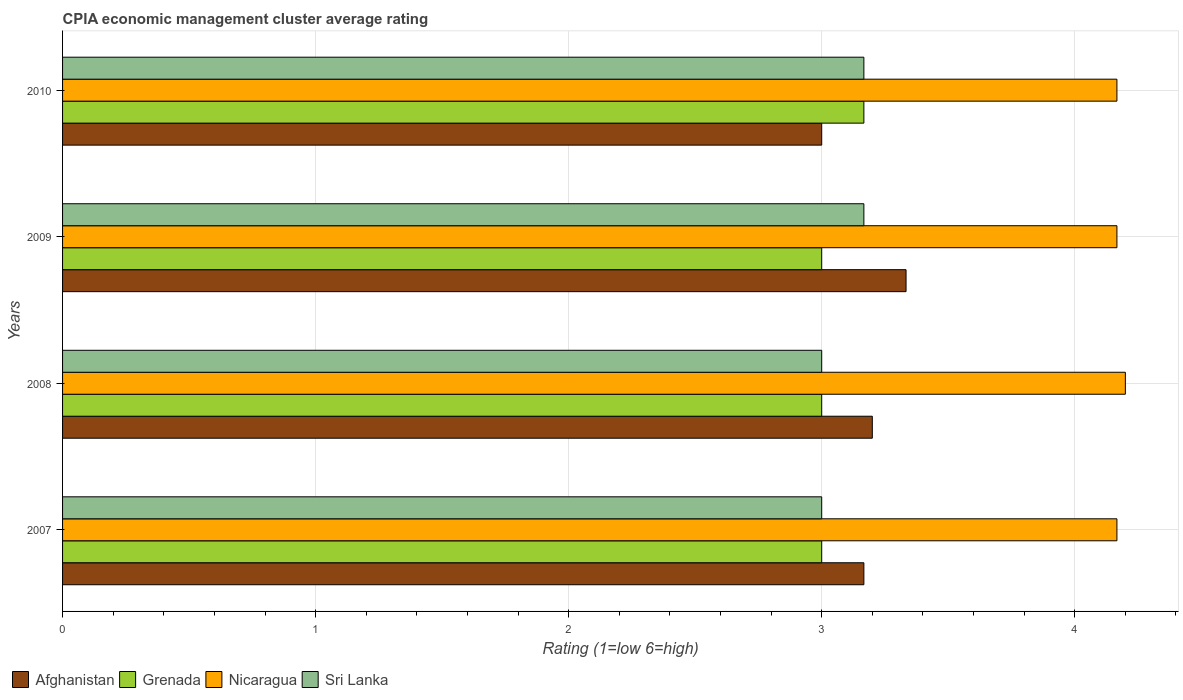How many different coloured bars are there?
Ensure brevity in your answer.  4. Are the number of bars per tick equal to the number of legend labels?
Offer a terse response. Yes. Are the number of bars on each tick of the Y-axis equal?
Your answer should be very brief. Yes. How many bars are there on the 2nd tick from the top?
Provide a succinct answer. 4. How many bars are there on the 3rd tick from the bottom?
Make the answer very short. 4. What is the CPIA rating in Nicaragua in 2007?
Provide a succinct answer. 4.17. Across all years, what is the maximum CPIA rating in Grenada?
Offer a terse response. 3.17. In which year was the CPIA rating in Afghanistan maximum?
Keep it short and to the point. 2009. What is the total CPIA rating in Afghanistan in the graph?
Provide a succinct answer. 12.7. What is the difference between the CPIA rating in Afghanistan in 2007 and that in 2009?
Offer a very short reply. -0.17. What is the difference between the CPIA rating in Nicaragua in 2009 and the CPIA rating in Afghanistan in 2007?
Provide a short and direct response. 1. What is the average CPIA rating in Nicaragua per year?
Give a very brief answer. 4.18. In the year 2009, what is the difference between the CPIA rating in Nicaragua and CPIA rating in Grenada?
Provide a succinct answer. 1.17. In how many years, is the CPIA rating in Afghanistan greater than 2.4 ?
Your answer should be compact. 4. What is the ratio of the CPIA rating in Sri Lanka in 2007 to that in 2010?
Offer a very short reply. 0.95. Is the CPIA rating in Grenada in 2007 less than that in 2009?
Offer a very short reply. No. What is the difference between the highest and the second highest CPIA rating in Afghanistan?
Make the answer very short. 0.13. What is the difference between the highest and the lowest CPIA rating in Afghanistan?
Make the answer very short. 0.33. In how many years, is the CPIA rating in Afghanistan greater than the average CPIA rating in Afghanistan taken over all years?
Provide a short and direct response. 2. Is the sum of the CPIA rating in Afghanistan in 2008 and 2010 greater than the maximum CPIA rating in Grenada across all years?
Keep it short and to the point. Yes. What does the 4th bar from the top in 2007 represents?
Provide a short and direct response. Afghanistan. What does the 4th bar from the bottom in 2008 represents?
Make the answer very short. Sri Lanka. How many bars are there?
Provide a succinct answer. 16. What is the difference between two consecutive major ticks on the X-axis?
Offer a terse response. 1. Are the values on the major ticks of X-axis written in scientific E-notation?
Offer a very short reply. No. Does the graph contain any zero values?
Make the answer very short. No. Does the graph contain grids?
Your answer should be compact. Yes. How many legend labels are there?
Offer a very short reply. 4. How are the legend labels stacked?
Provide a succinct answer. Horizontal. What is the title of the graph?
Provide a short and direct response. CPIA economic management cluster average rating. Does "Germany" appear as one of the legend labels in the graph?
Provide a succinct answer. No. What is the label or title of the X-axis?
Ensure brevity in your answer.  Rating (1=low 6=high). What is the Rating (1=low 6=high) in Afghanistan in 2007?
Your response must be concise. 3.17. What is the Rating (1=low 6=high) in Grenada in 2007?
Your response must be concise. 3. What is the Rating (1=low 6=high) in Nicaragua in 2007?
Ensure brevity in your answer.  4.17. What is the Rating (1=low 6=high) in Nicaragua in 2008?
Your answer should be compact. 4.2. What is the Rating (1=low 6=high) in Afghanistan in 2009?
Ensure brevity in your answer.  3.33. What is the Rating (1=low 6=high) in Grenada in 2009?
Make the answer very short. 3. What is the Rating (1=low 6=high) of Nicaragua in 2009?
Offer a very short reply. 4.17. What is the Rating (1=low 6=high) of Sri Lanka in 2009?
Give a very brief answer. 3.17. What is the Rating (1=low 6=high) of Grenada in 2010?
Keep it short and to the point. 3.17. What is the Rating (1=low 6=high) of Nicaragua in 2010?
Ensure brevity in your answer.  4.17. What is the Rating (1=low 6=high) of Sri Lanka in 2010?
Keep it short and to the point. 3.17. Across all years, what is the maximum Rating (1=low 6=high) of Afghanistan?
Keep it short and to the point. 3.33. Across all years, what is the maximum Rating (1=low 6=high) in Grenada?
Your answer should be compact. 3.17. Across all years, what is the maximum Rating (1=low 6=high) in Nicaragua?
Your answer should be very brief. 4.2. Across all years, what is the maximum Rating (1=low 6=high) of Sri Lanka?
Your answer should be very brief. 3.17. Across all years, what is the minimum Rating (1=low 6=high) of Afghanistan?
Give a very brief answer. 3. Across all years, what is the minimum Rating (1=low 6=high) in Grenada?
Offer a terse response. 3. Across all years, what is the minimum Rating (1=low 6=high) of Nicaragua?
Offer a very short reply. 4.17. Across all years, what is the minimum Rating (1=low 6=high) of Sri Lanka?
Provide a succinct answer. 3. What is the total Rating (1=low 6=high) of Grenada in the graph?
Give a very brief answer. 12.17. What is the total Rating (1=low 6=high) in Nicaragua in the graph?
Your answer should be very brief. 16.7. What is the total Rating (1=low 6=high) in Sri Lanka in the graph?
Make the answer very short. 12.33. What is the difference between the Rating (1=low 6=high) in Afghanistan in 2007 and that in 2008?
Provide a succinct answer. -0.03. What is the difference between the Rating (1=low 6=high) in Grenada in 2007 and that in 2008?
Give a very brief answer. 0. What is the difference between the Rating (1=low 6=high) of Nicaragua in 2007 and that in 2008?
Make the answer very short. -0.03. What is the difference between the Rating (1=low 6=high) in Afghanistan in 2007 and that in 2009?
Provide a succinct answer. -0.17. What is the difference between the Rating (1=low 6=high) in Sri Lanka in 2007 and that in 2009?
Give a very brief answer. -0.17. What is the difference between the Rating (1=low 6=high) in Grenada in 2007 and that in 2010?
Offer a terse response. -0.17. What is the difference between the Rating (1=low 6=high) in Nicaragua in 2007 and that in 2010?
Give a very brief answer. 0. What is the difference between the Rating (1=low 6=high) in Sri Lanka in 2007 and that in 2010?
Your answer should be very brief. -0.17. What is the difference between the Rating (1=low 6=high) of Afghanistan in 2008 and that in 2009?
Your answer should be compact. -0.13. What is the difference between the Rating (1=low 6=high) in Grenada in 2008 and that in 2010?
Keep it short and to the point. -0.17. What is the difference between the Rating (1=low 6=high) in Sri Lanka in 2008 and that in 2010?
Your response must be concise. -0.17. What is the difference between the Rating (1=low 6=high) in Nicaragua in 2009 and that in 2010?
Make the answer very short. 0. What is the difference between the Rating (1=low 6=high) of Afghanistan in 2007 and the Rating (1=low 6=high) of Nicaragua in 2008?
Your answer should be compact. -1.03. What is the difference between the Rating (1=low 6=high) in Grenada in 2007 and the Rating (1=low 6=high) in Nicaragua in 2008?
Your answer should be very brief. -1.2. What is the difference between the Rating (1=low 6=high) in Grenada in 2007 and the Rating (1=low 6=high) in Sri Lanka in 2008?
Your answer should be very brief. 0. What is the difference between the Rating (1=low 6=high) in Nicaragua in 2007 and the Rating (1=low 6=high) in Sri Lanka in 2008?
Your answer should be compact. 1.17. What is the difference between the Rating (1=low 6=high) in Afghanistan in 2007 and the Rating (1=low 6=high) in Grenada in 2009?
Provide a short and direct response. 0.17. What is the difference between the Rating (1=low 6=high) in Afghanistan in 2007 and the Rating (1=low 6=high) in Sri Lanka in 2009?
Your answer should be compact. 0. What is the difference between the Rating (1=low 6=high) in Grenada in 2007 and the Rating (1=low 6=high) in Nicaragua in 2009?
Keep it short and to the point. -1.17. What is the difference between the Rating (1=low 6=high) of Afghanistan in 2007 and the Rating (1=low 6=high) of Grenada in 2010?
Provide a succinct answer. 0. What is the difference between the Rating (1=low 6=high) of Grenada in 2007 and the Rating (1=low 6=high) of Nicaragua in 2010?
Your response must be concise. -1.17. What is the difference between the Rating (1=low 6=high) in Grenada in 2007 and the Rating (1=low 6=high) in Sri Lanka in 2010?
Ensure brevity in your answer.  -0.17. What is the difference between the Rating (1=low 6=high) in Nicaragua in 2007 and the Rating (1=low 6=high) in Sri Lanka in 2010?
Provide a short and direct response. 1. What is the difference between the Rating (1=low 6=high) of Afghanistan in 2008 and the Rating (1=low 6=high) of Grenada in 2009?
Keep it short and to the point. 0.2. What is the difference between the Rating (1=low 6=high) in Afghanistan in 2008 and the Rating (1=low 6=high) in Nicaragua in 2009?
Your response must be concise. -0.97. What is the difference between the Rating (1=low 6=high) in Afghanistan in 2008 and the Rating (1=low 6=high) in Sri Lanka in 2009?
Offer a very short reply. 0.03. What is the difference between the Rating (1=low 6=high) in Grenada in 2008 and the Rating (1=low 6=high) in Nicaragua in 2009?
Offer a very short reply. -1.17. What is the difference between the Rating (1=low 6=high) of Grenada in 2008 and the Rating (1=low 6=high) of Sri Lanka in 2009?
Your response must be concise. -0.17. What is the difference between the Rating (1=low 6=high) of Afghanistan in 2008 and the Rating (1=low 6=high) of Grenada in 2010?
Your response must be concise. 0.03. What is the difference between the Rating (1=low 6=high) in Afghanistan in 2008 and the Rating (1=low 6=high) in Nicaragua in 2010?
Offer a very short reply. -0.97. What is the difference between the Rating (1=low 6=high) in Afghanistan in 2008 and the Rating (1=low 6=high) in Sri Lanka in 2010?
Your answer should be very brief. 0.03. What is the difference between the Rating (1=low 6=high) of Grenada in 2008 and the Rating (1=low 6=high) of Nicaragua in 2010?
Keep it short and to the point. -1.17. What is the difference between the Rating (1=low 6=high) in Grenada in 2008 and the Rating (1=low 6=high) in Sri Lanka in 2010?
Offer a very short reply. -0.17. What is the difference between the Rating (1=low 6=high) of Grenada in 2009 and the Rating (1=low 6=high) of Nicaragua in 2010?
Make the answer very short. -1.17. What is the difference between the Rating (1=low 6=high) in Grenada in 2009 and the Rating (1=low 6=high) in Sri Lanka in 2010?
Make the answer very short. -0.17. What is the difference between the Rating (1=low 6=high) of Nicaragua in 2009 and the Rating (1=low 6=high) of Sri Lanka in 2010?
Your answer should be very brief. 1. What is the average Rating (1=low 6=high) in Afghanistan per year?
Your response must be concise. 3.17. What is the average Rating (1=low 6=high) of Grenada per year?
Ensure brevity in your answer.  3.04. What is the average Rating (1=low 6=high) of Nicaragua per year?
Your answer should be compact. 4.17. What is the average Rating (1=low 6=high) in Sri Lanka per year?
Provide a short and direct response. 3.08. In the year 2007, what is the difference between the Rating (1=low 6=high) of Afghanistan and Rating (1=low 6=high) of Nicaragua?
Make the answer very short. -1. In the year 2007, what is the difference between the Rating (1=low 6=high) of Grenada and Rating (1=low 6=high) of Nicaragua?
Give a very brief answer. -1.17. In the year 2008, what is the difference between the Rating (1=low 6=high) of Afghanistan and Rating (1=low 6=high) of Grenada?
Offer a very short reply. 0.2. In the year 2008, what is the difference between the Rating (1=low 6=high) of Grenada and Rating (1=low 6=high) of Nicaragua?
Offer a terse response. -1.2. In the year 2008, what is the difference between the Rating (1=low 6=high) in Grenada and Rating (1=low 6=high) in Sri Lanka?
Give a very brief answer. 0. In the year 2008, what is the difference between the Rating (1=low 6=high) in Nicaragua and Rating (1=low 6=high) in Sri Lanka?
Your answer should be very brief. 1.2. In the year 2009, what is the difference between the Rating (1=low 6=high) of Afghanistan and Rating (1=low 6=high) of Grenada?
Provide a short and direct response. 0.33. In the year 2009, what is the difference between the Rating (1=low 6=high) of Afghanistan and Rating (1=low 6=high) of Nicaragua?
Keep it short and to the point. -0.83. In the year 2009, what is the difference between the Rating (1=low 6=high) of Afghanistan and Rating (1=low 6=high) of Sri Lanka?
Your answer should be very brief. 0.17. In the year 2009, what is the difference between the Rating (1=low 6=high) in Grenada and Rating (1=low 6=high) in Nicaragua?
Keep it short and to the point. -1.17. In the year 2009, what is the difference between the Rating (1=low 6=high) of Nicaragua and Rating (1=low 6=high) of Sri Lanka?
Offer a terse response. 1. In the year 2010, what is the difference between the Rating (1=low 6=high) in Afghanistan and Rating (1=low 6=high) in Grenada?
Provide a succinct answer. -0.17. In the year 2010, what is the difference between the Rating (1=low 6=high) of Afghanistan and Rating (1=low 6=high) of Nicaragua?
Provide a short and direct response. -1.17. In the year 2010, what is the difference between the Rating (1=low 6=high) in Grenada and Rating (1=low 6=high) in Nicaragua?
Your answer should be compact. -1. In the year 2010, what is the difference between the Rating (1=low 6=high) in Grenada and Rating (1=low 6=high) in Sri Lanka?
Give a very brief answer. 0. In the year 2010, what is the difference between the Rating (1=low 6=high) in Nicaragua and Rating (1=low 6=high) in Sri Lanka?
Offer a very short reply. 1. What is the ratio of the Rating (1=low 6=high) of Sri Lanka in 2007 to that in 2008?
Provide a succinct answer. 1. What is the ratio of the Rating (1=low 6=high) in Afghanistan in 2007 to that in 2010?
Your response must be concise. 1.06. What is the ratio of the Rating (1=low 6=high) in Nicaragua in 2007 to that in 2010?
Your answer should be very brief. 1. What is the ratio of the Rating (1=low 6=high) in Sri Lanka in 2007 to that in 2010?
Provide a succinct answer. 0.95. What is the ratio of the Rating (1=low 6=high) of Afghanistan in 2008 to that in 2009?
Ensure brevity in your answer.  0.96. What is the ratio of the Rating (1=low 6=high) of Grenada in 2008 to that in 2009?
Offer a very short reply. 1. What is the ratio of the Rating (1=low 6=high) of Afghanistan in 2008 to that in 2010?
Your answer should be compact. 1.07. What is the ratio of the Rating (1=low 6=high) in Grenada in 2009 to that in 2010?
Ensure brevity in your answer.  0.95. What is the ratio of the Rating (1=low 6=high) of Sri Lanka in 2009 to that in 2010?
Make the answer very short. 1. What is the difference between the highest and the second highest Rating (1=low 6=high) of Afghanistan?
Your response must be concise. 0.13. What is the difference between the highest and the second highest Rating (1=low 6=high) in Nicaragua?
Offer a terse response. 0.03. What is the difference between the highest and the lowest Rating (1=low 6=high) in Afghanistan?
Make the answer very short. 0.33. What is the difference between the highest and the lowest Rating (1=low 6=high) in Sri Lanka?
Your response must be concise. 0.17. 